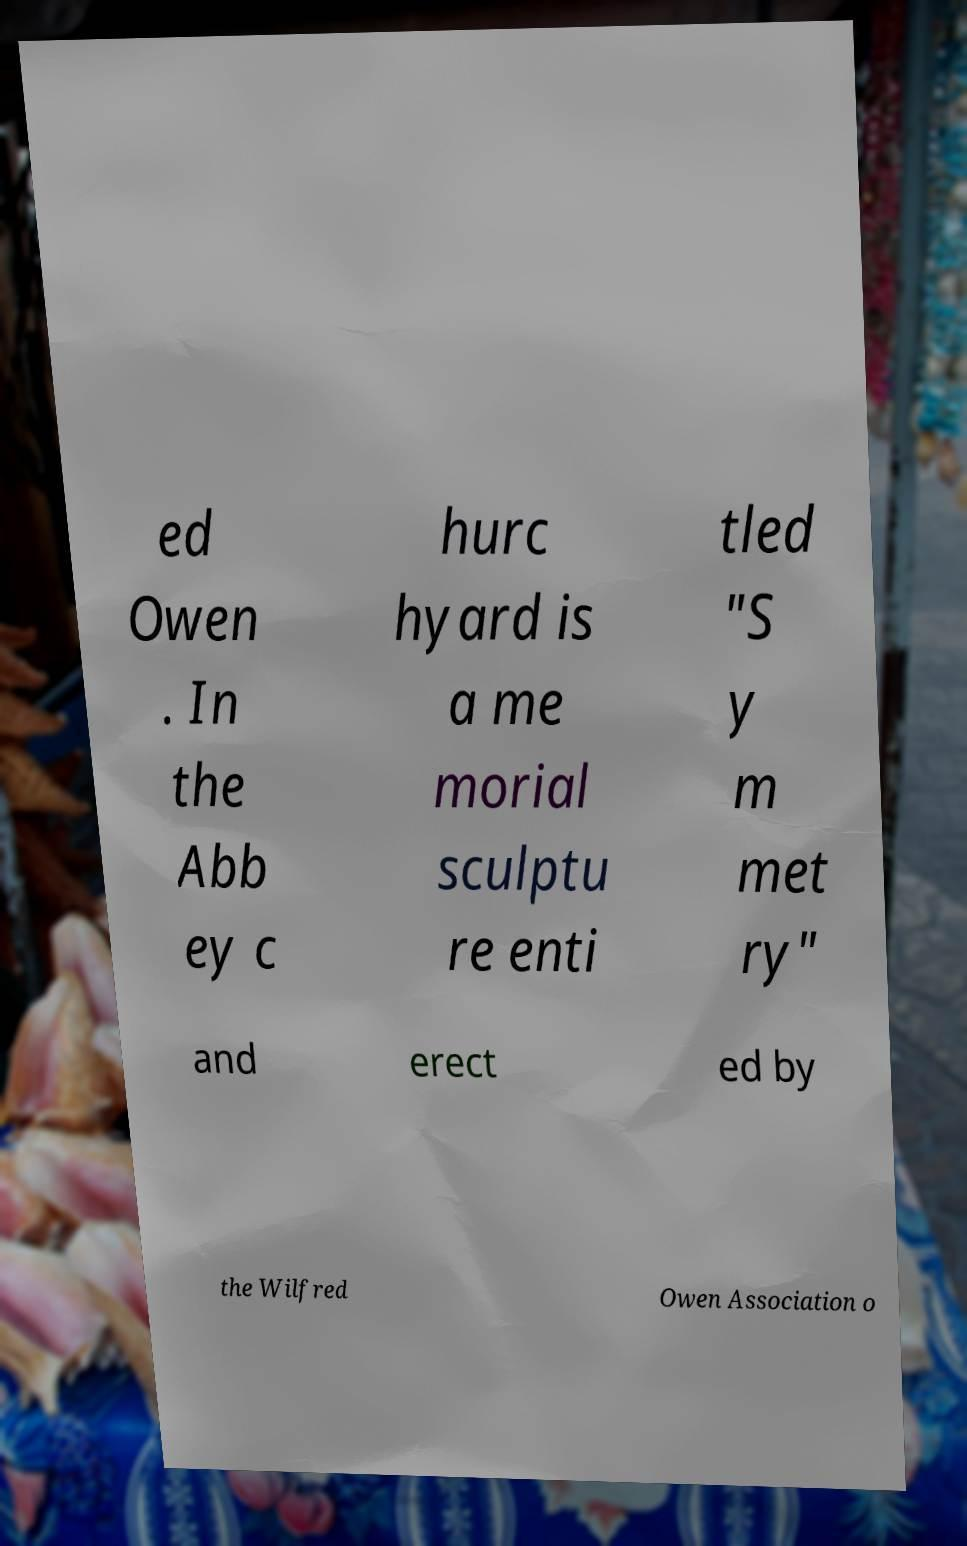Please identify and transcribe the text found in this image. ed Owen . In the Abb ey c hurc hyard is a me morial sculptu re enti tled "S y m met ry" and erect ed by the Wilfred Owen Association o 